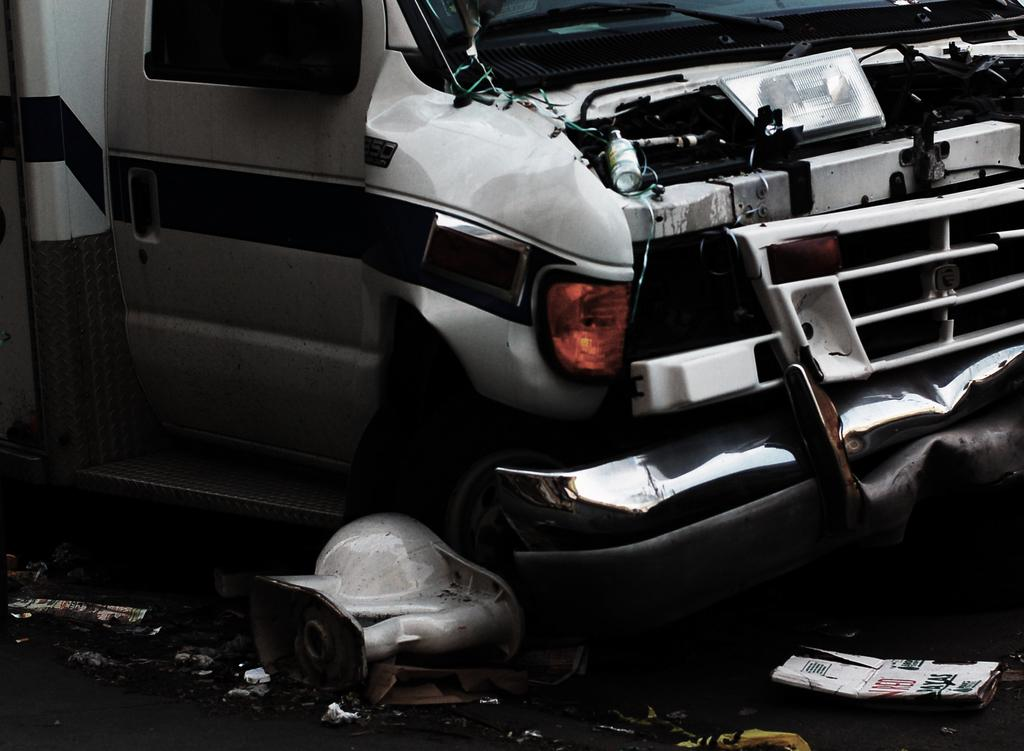What is the main subject of the image? The main subject of the image is a damaged vehicle. Can you describe the condition of the vehicle? The vehicle appears to be damaged, as indicated by the facts. What else can be seen related to the vehicle in the image? There are parts of the vehicle on the ground in the image. What type of pan can be seen being used to fire the cannon in the image? There is no pan or cannon present in the image; it features a damaged vehicle with parts on the ground. What type of observation can be made about the vehicle's condition in the image? The vehicle's condition in the image is that it appears to be damaged, as indicated by the facts. 